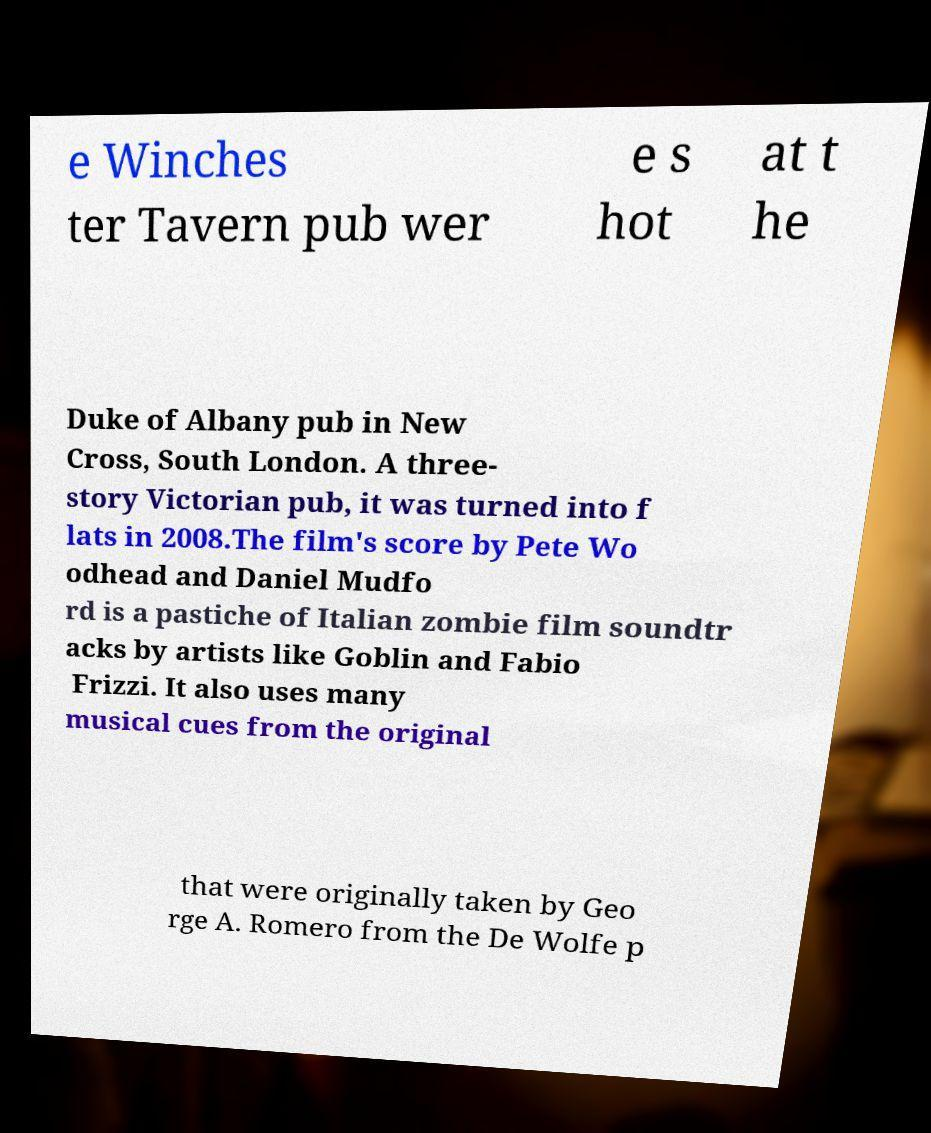What messages or text are displayed in this image? I need them in a readable, typed format. e Winches ter Tavern pub wer e s hot at t he Duke of Albany pub in New Cross, South London. A three- story Victorian pub, it was turned into f lats in 2008.The film's score by Pete Wo odhead and Daniel Mudfo rd is a pastiche of Italian zombie film soundtr acks by artists like Goblin and Fabio Frizzi. It also uses many musical cues from the original that were originally taken by Geo rge A. Romero from the De Wolfe p 